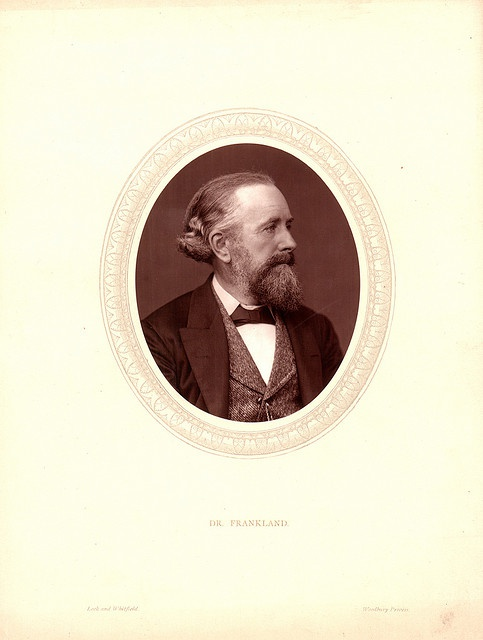Describe the objects in this image and their specific colors. I can see people in beige, maroon, black, brown, and ivory tones and tie in beige, black, maroon, and brown tones in this image. 